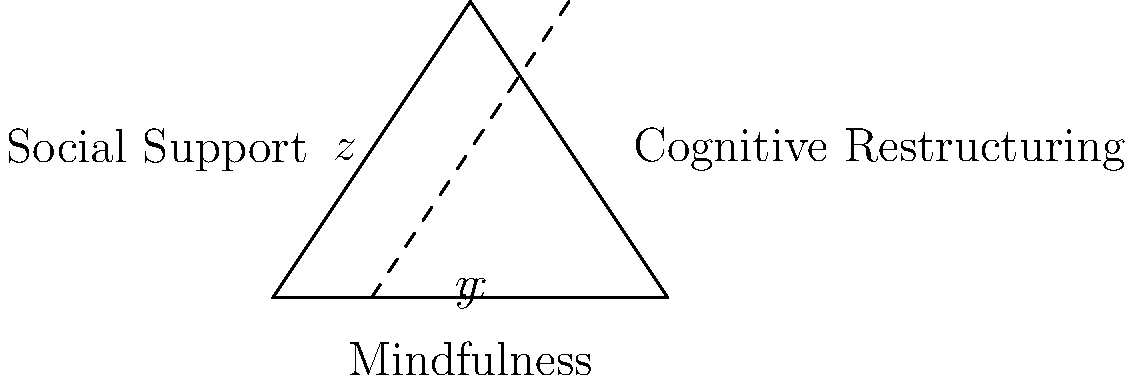In the diagram, three psychological coping strategies for space travel aftermath are represented by the sides of a triangle. The angle formed at the intersection of "Mindfulness" and "Cognitive Restructuring" is bisected by a line representing a combined approach. If $x°$, $y°$, and $z°$ are the measures of the angles as shown, what is the value of $x + y + z$? Let's approach this step-by-step:

1) First, recall that the sum of angles in a triangle is always 180°.

2) The line bisecting the angle at the base of the triangle creates two congruent angles, $x°$ and $y°$.

3) The angle at the top of the triangle is split into two parts by the dashed line. One part is $z°$, and the other part is equal to $x°$ (alternate angles are equal when a line intersects two parallel lines).

4) So, we can express the sum of angles in the triangle as:
   $x° + y° + z° + x° = 180°$

5) Since $x° = y°$ (from step 2), we can rewrite this as:
   $x° + x° + z° + x° = 180°$
   $3x° + z° = 180°$

6) The question asks for $x + y + z$. We know $x = y$, so this is equivalent to $2x + z$.

7) From the equation in step 5, we can see that $2x + z$ is simply $180° - x°$.

8) Therefore, regardless of the individual values of $x$, $y$, and $z$, their sum $x + y + z$ (which is the same as $2x + z$) will always equal $180° - x°$, which is always equal to $180°$.
Answer: $180°$ 